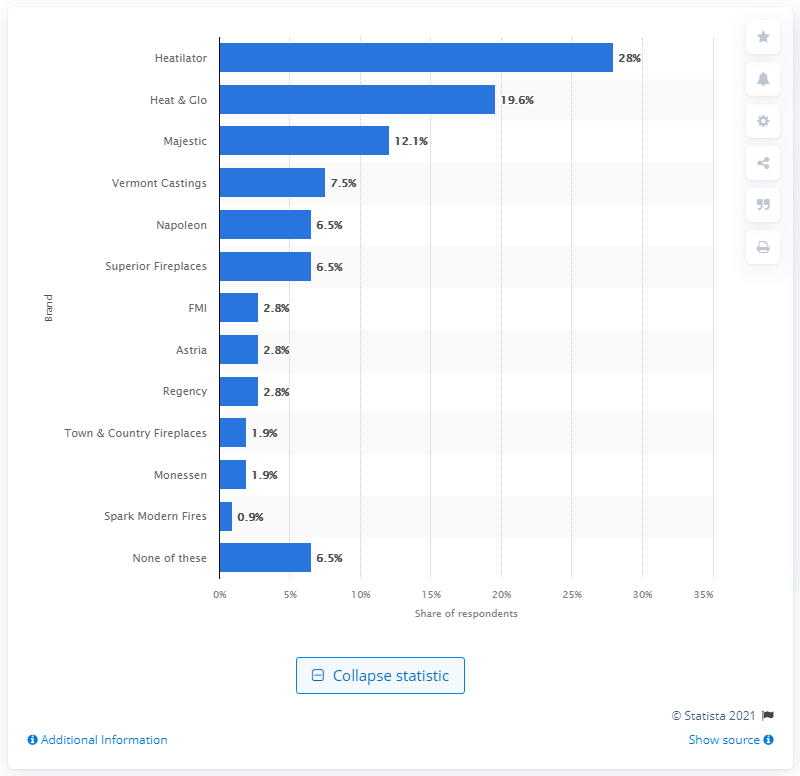Draw attention to some important aspects in this diagram. According to the survey, Heatilator was the brand of fireplace that 28% of respondents reported using the most. 